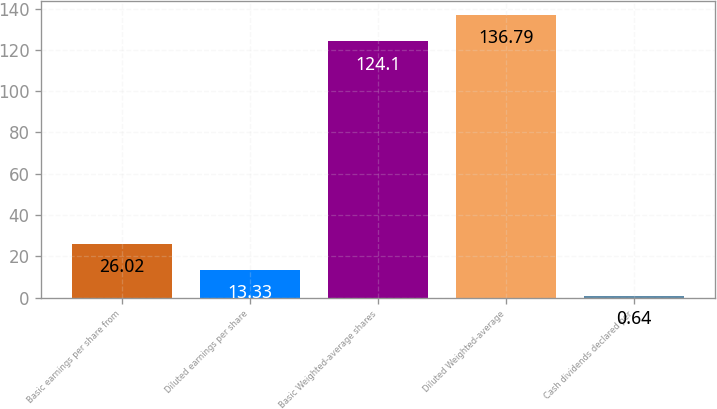Convert chart. <chart><loc_0><loc_0><loc_500><loc_500><bar_chart><fcel>Basic earnings per share from<fcel>Diluted earnings per share<fcel>Basic Weighted-average shares<fcel>Diluted Weighted-average<fcel>Cash dividends declared per<nl><fcel>26.02<fcel>13.33<fcel>124.1<fcel>136.79<fcel>0.64<nl></chart> 